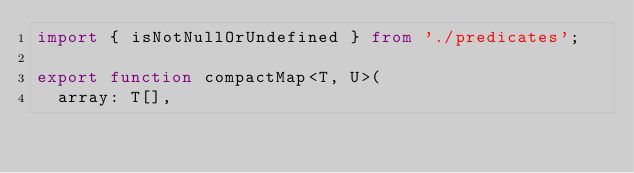Convert code to text. <code><loc_0><loc_0><loc_500><loc_500><_TypeScript_>import { isNotNullOrUndefined } from './predicates';

export function compactMap<T, U>(
  array: T[],</code> 